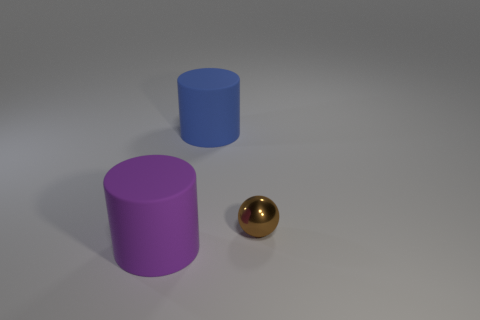Add 3 shiny spheres. How many objects exist? 6 Subtract all cylinders. How many objects are left? 1 Subtract all small brown shiny balls. Subtract all tiny brown spheres. How many objects are left? 1 Add 2 rubber objects. How many rubber objects are left? 4 Add 2 big cylinders. How many big cylinders exist? 4 Subtract 0 yellow balls. How many objects are left? 3 